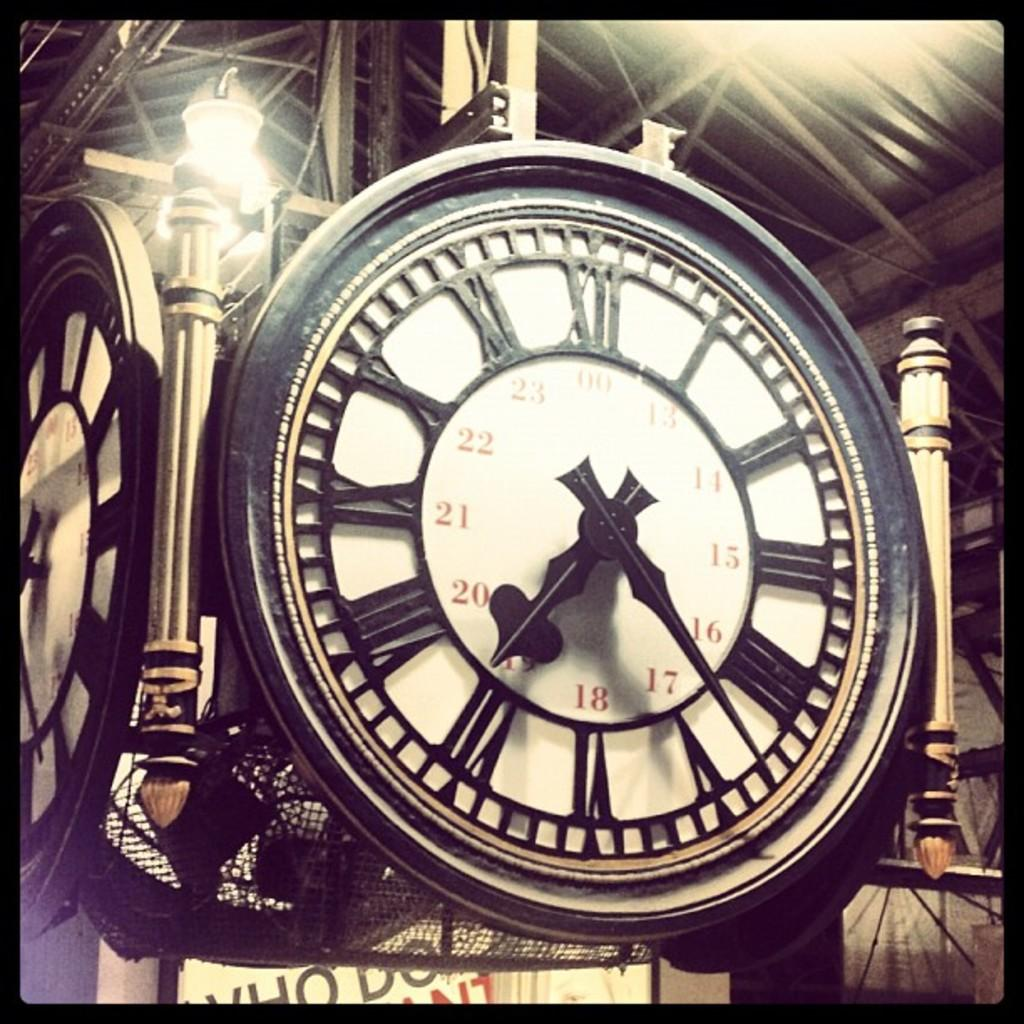<image>
Provide a brief description of the given image. a metal rod iron clock set at the time of 7:23 